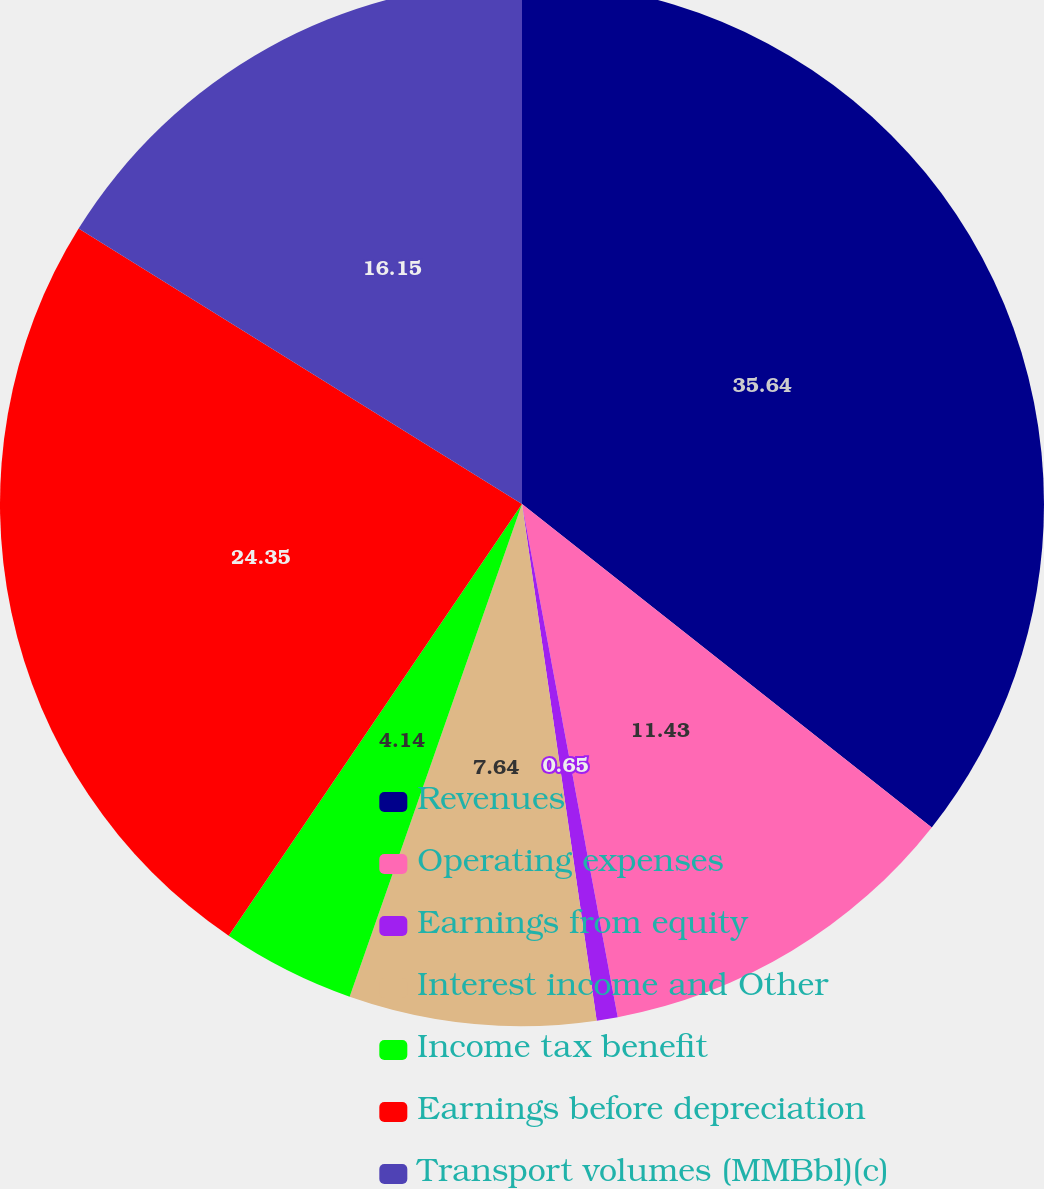Convert chart to OTSL. <chart><loc_0><loc_0><loc_500><loc_500><pie_chart><fcel>Revenues<fcel>Operating expenses<fcel>Earnings from equity<fcel>Interest income and Other<fcel>Income tax benefit<fcel>Earnings before depreciation<fcel>Transport volumes (MMBbl)(c)<nl><fcel>35.63%<fcel>11.43%<fcel>0.65%<fcel>7.64%<fcel>4.14%<fcel>24.35%<fcel>16.15%<nl></chart> 